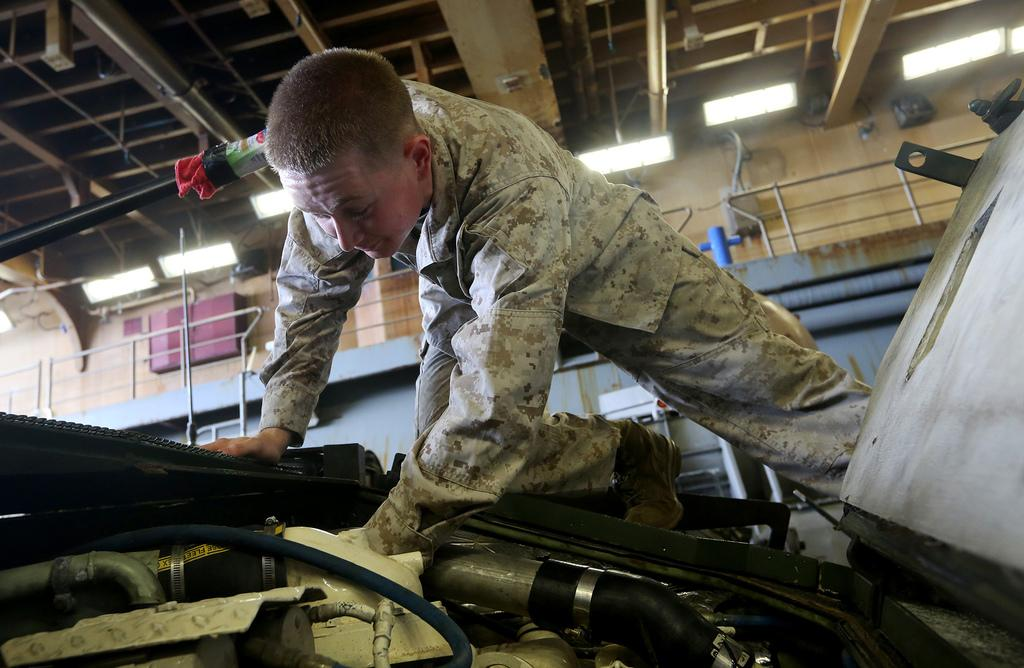What can be seen in the image? There is a person in the image. What is the person wearing? The person is wearing a dress. What mode of transportation is the person using? The person is on a vehicle. What type of vehicle is it? The vehicle has an engine. What can be seen in the background of the image? The background of the image is blurred, and the ceiling is visible. What is the income of the person in the image? There is no information about the person's income in the image. What is the condition of the sun in the image? The sun is not visible in the image, so its condition cannot be determined. 